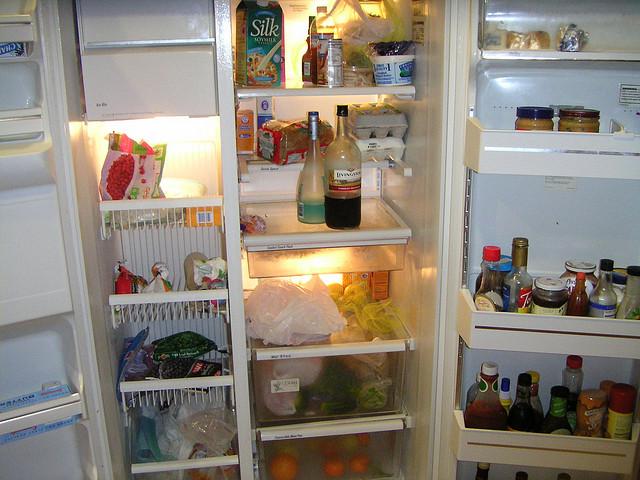Are the two egg cartons exactly alike?
Quick response, please. No. Is the fridge light working?
Be succinct. Yes. What is the brand of the carton on the top shelf?
Write a very short answer. Silk. 